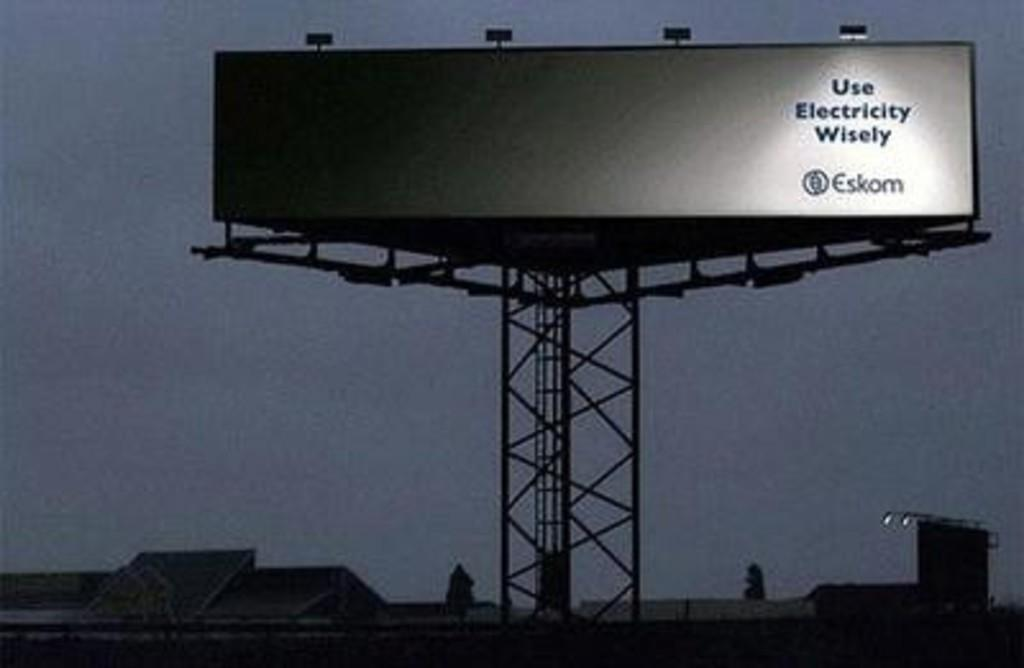<image>
Present a compact description of the photo's key features. A BILLBOARD THAT SAYS "USE ELECTRICITY WISELY" BY THE COMPANY ESKOM. 